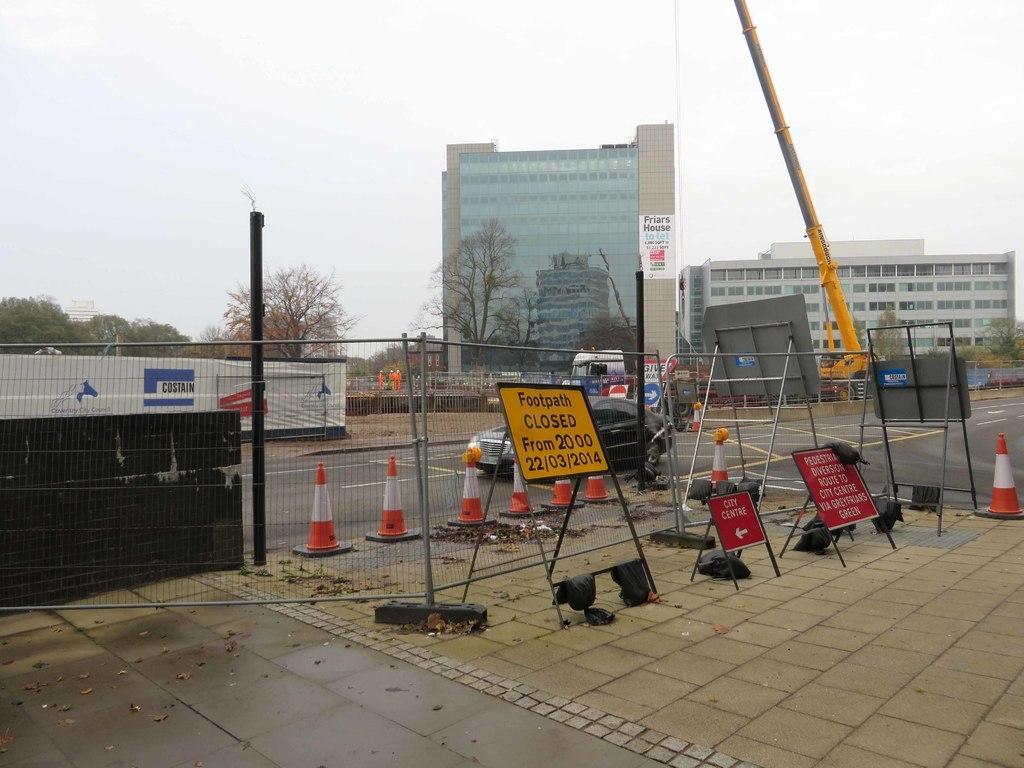Could you give a brief overview of what you see in this image? In this picture, we can see the path with some objects, like board with some text, poles, fencing, posters with text, road, a few vehicles, glass building, buildings with windows, trees, crane, and the sky and a few people. 